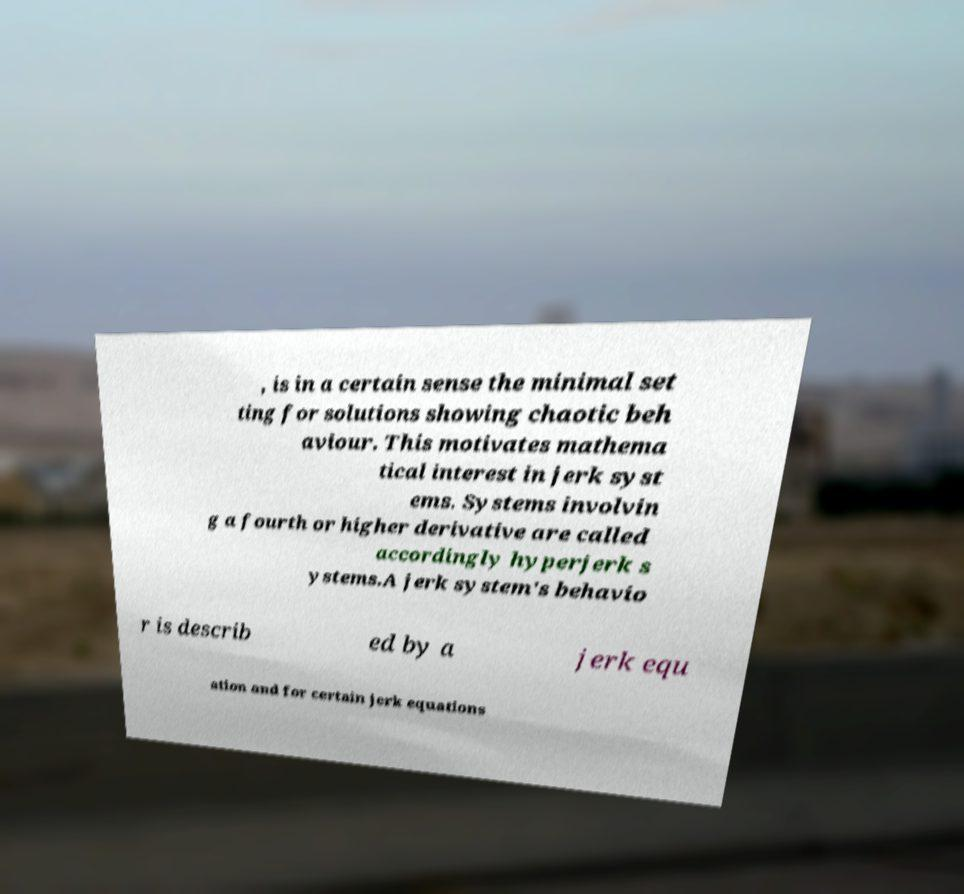Can you accurately transcribe the text from the provided image for me? , is in a certain sense the minimal set ting for solutions showing chaotic beh aviour. This motivates mathema tical interest in jerk syst ems. Systems involvin g a fourth or higher derivative are called accordingly hyperjerk s ystems.A jerk system's behavio r is describ ed by a jerk equ ation and for certain jerk equations 